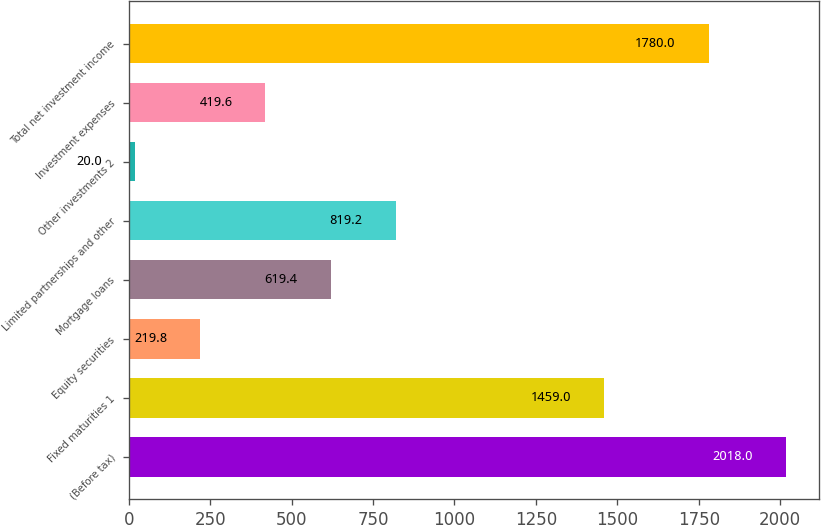Convert chart to OTSL. <chart><loc_0><loc_0><loc_500><loc_500><bar_chart><fcel>(Before tax)<fcel>Fixed maturities 1<fcel>Equity securities<fcel>Mortgage loans<fcel>Limited partnerships and other<fcel>Other investments 2<fcel>Investment expenses<fcel>Total net investment income<nl><fcel>2018<fcel>1459<fcel>219.8<fcel>619.4<fcel>819.2<fcel>20<fcel>419.6<fcel>1780<nl></chart> 